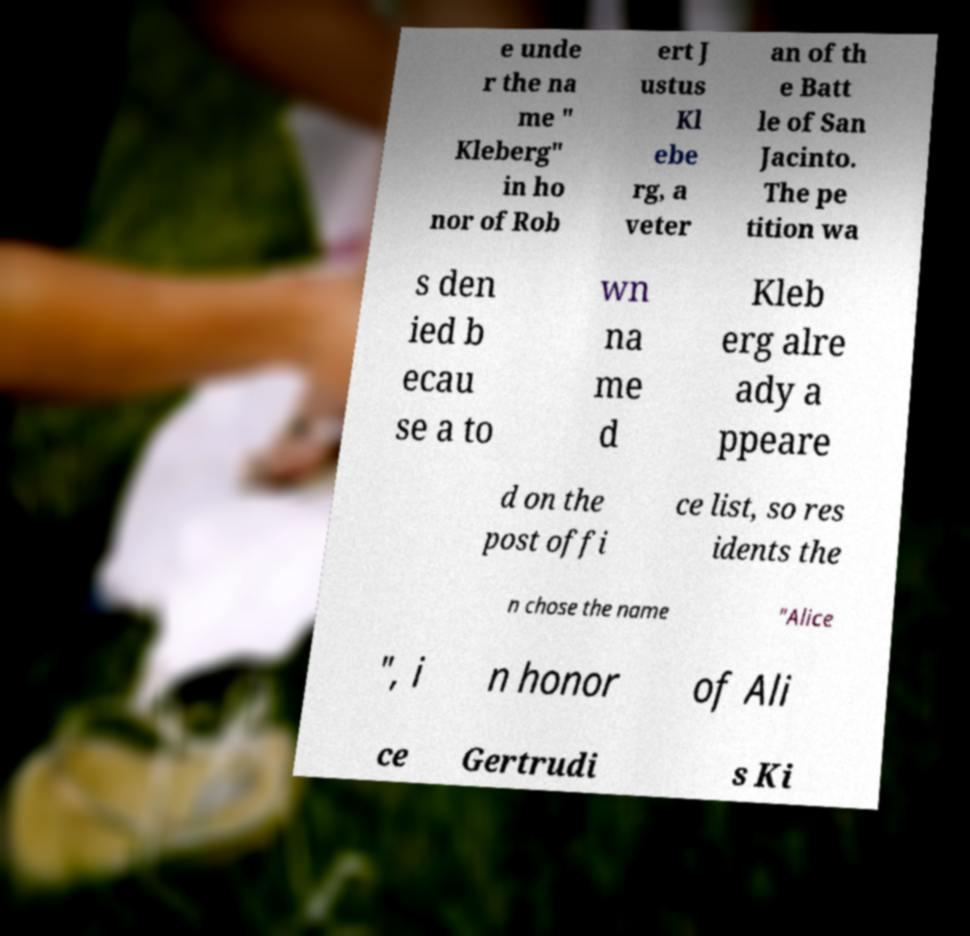There's text embedded in this image that I need extracted. Can you transcribe it verbatim? e unde r the na me " Kleberg" in ho nor of Rob ert J ustus Kl ebe rg, a veter an of th e Batt le of San Jacinto. The pe tition wa s den ied b ecau se a to wn na me d Kleb erg alre ady a ppeare d on the post offi ce list, so res idents the n chose the name "Alice ", i n honor of Ali ce Gertrudi s Ki 